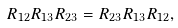Convert formula to latex. <formula><loc_0><loc_0><loc_500><loc_500>R _ { 1 2 } R _ { 1 3 } R _ { 2 3 } = R _ { 2 3 } R _ { 1 3 } R _ { 1 2 } ,</formula> 